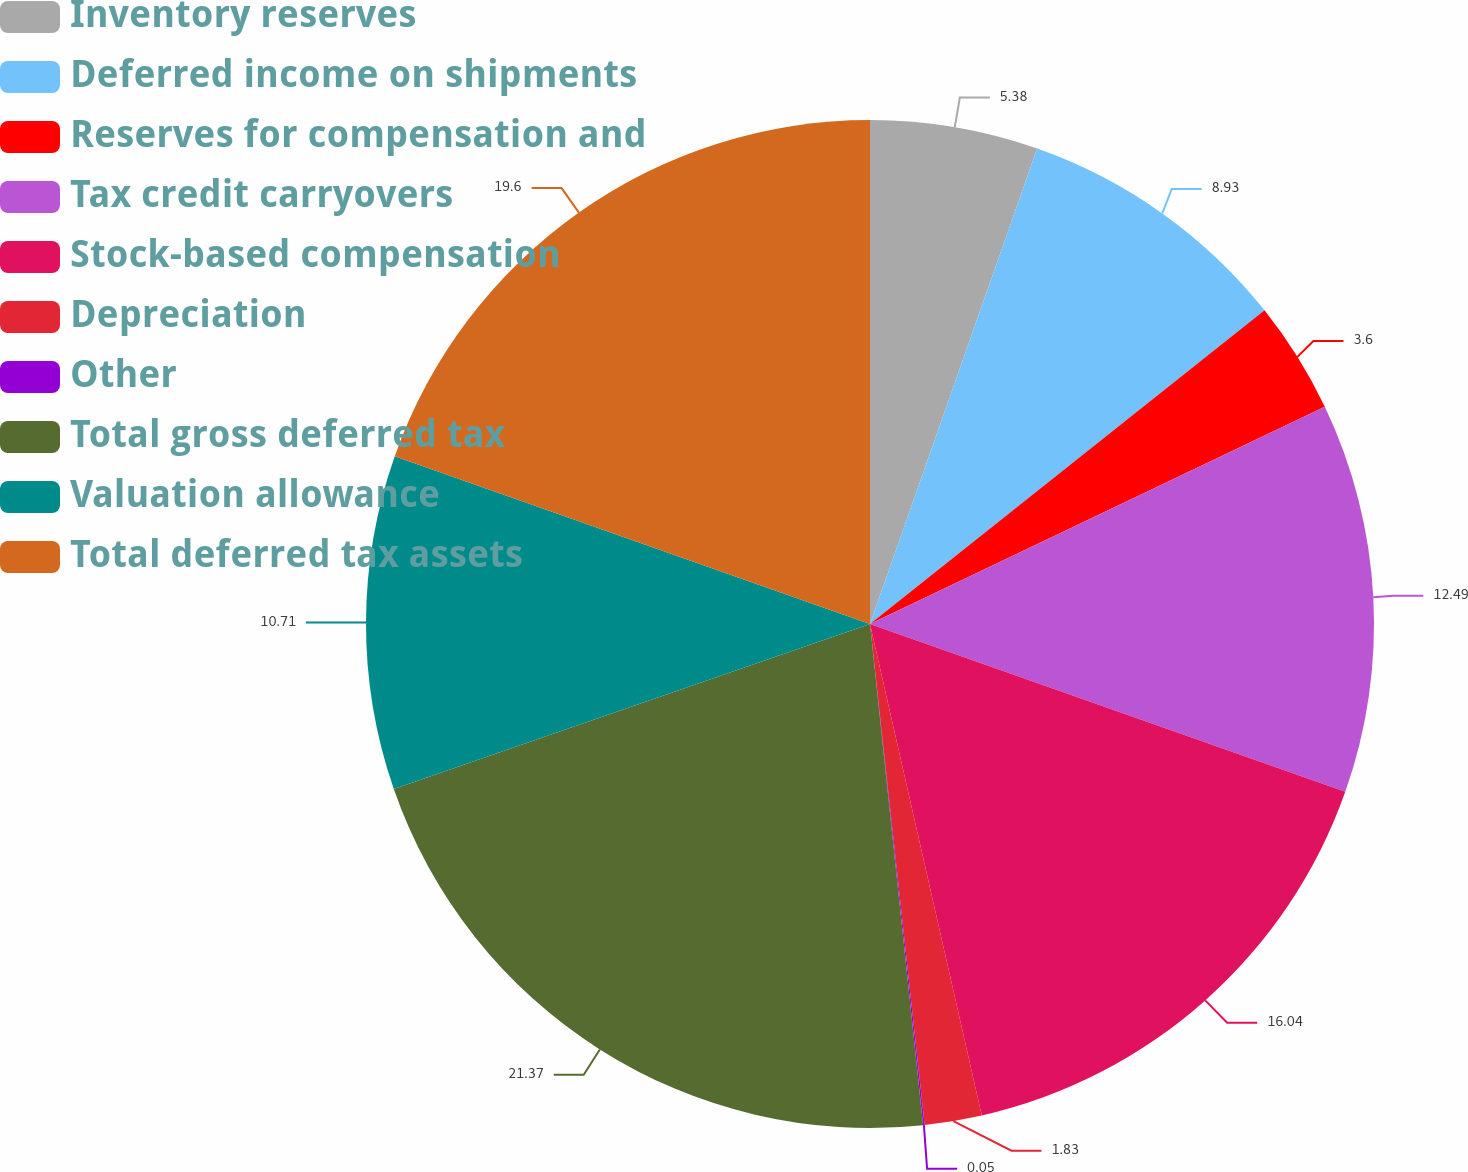Convert chart. <chart><loc_0><loc_0><loc_500><loc_500><pie_chart><fcel>Inventory reserves<fcel>Deferred income on shipments<fcel>Reserves for compensation and<fcel>Tax credit carryovers<fcel>Stock-based compensation<fcel>Depreciation<fcel>Other<fcel>Total gross deferred tax<fcel>Valuation allowance<fcel>Total deferred tax assets<nl><fcel>5.38%<fcel>8.93%<fcel>3.6%<fcel>12.49%<fcel>16.04%<fcel>1.83%<fcel>0.05%<fcel>21.37%<fcel>10.71%<fcel>19.6%<nl></chart> 